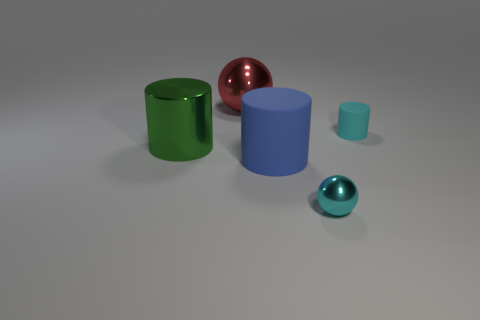How do the textures of the various objects compare? The objects in the image appear to have smooth textures with a polished finish. The reflection and shine on their surfaces suggest that they are likely made from materials with metallic or plastic properties, providing a sleek and modern appearance. 